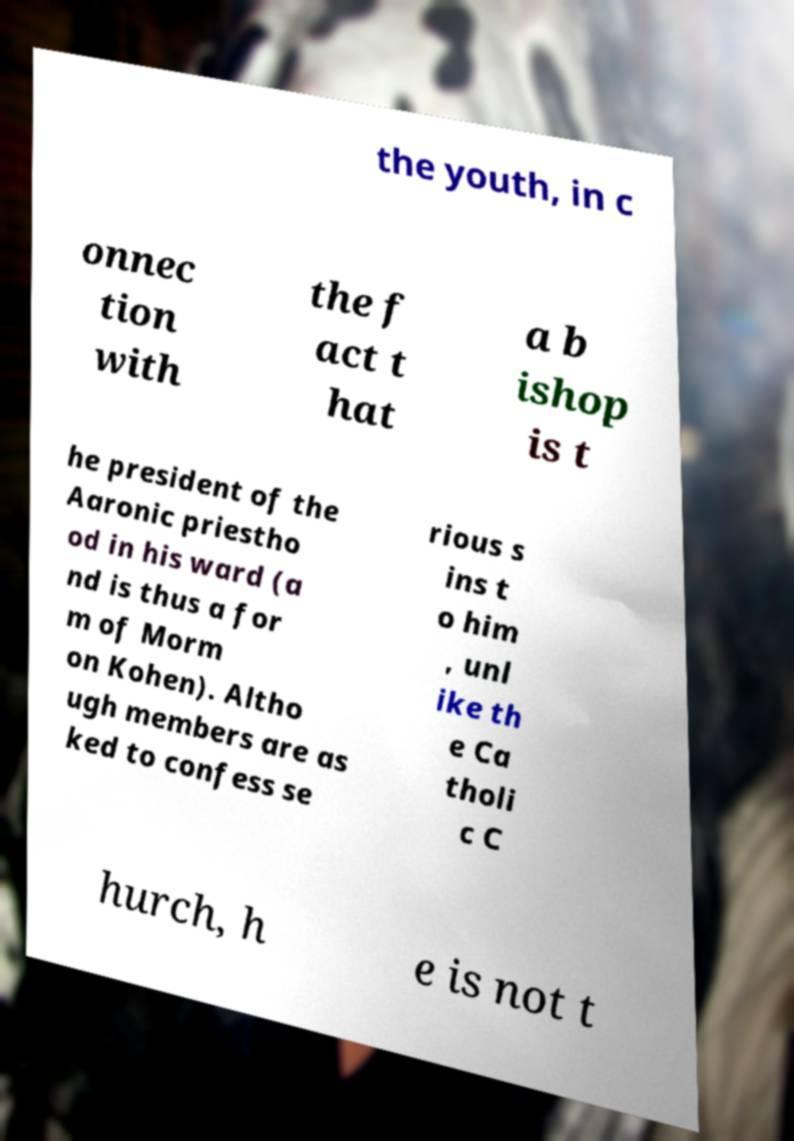Can you accurately transcribe the text from the provided image for me? the youth, in c onnec tion with the f act t hat a b ishop is t he president of the Aaronic priestho od in his ward (a nd is thus a for m of Morm on Kohen). Altho ugh members are as ked to confess se rious s ins t o him , unl ike th e Ca tholi c C hurch, h e is not t 